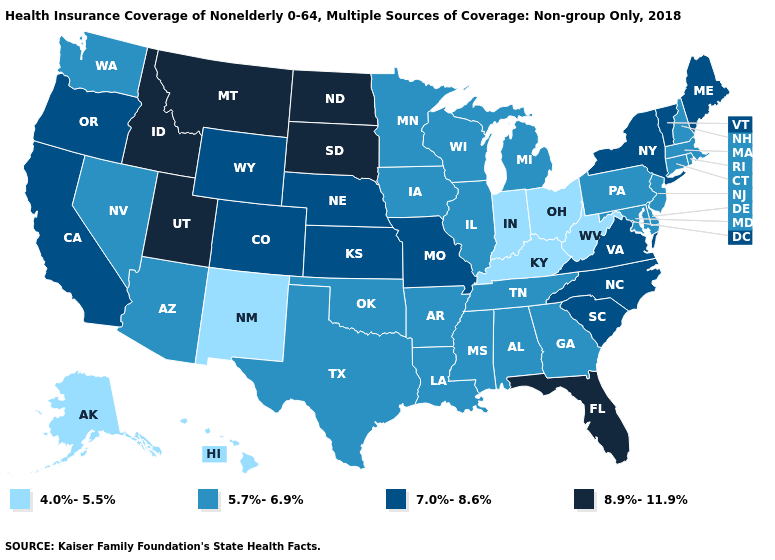What is the highest value in the USA?
Write a very short answer. 8.9%-11.9%. What is the value of South Carolina?
Concise answer only. 7.0%-8.6%. Among the states that border Vermont , which have the lowest value?
Concise answer only. Massachusetts, New Hampshire. Which states have the highest value in the USA?
Write a very short answer. Florida, Idaho, Montana, North Dakota, South Dakota, Utah. Among the states that border South Carolina , which have the highest value?
Write a very short answer. North Carolina. What is the value of Florida?
Answer briefly. 8.9%-11.9%. What is the value of Pennsylvania?
Write a very short answer. 5.7%-6.9%. What is the value of Washington?
Write a very short answer. 5.7%-6.9%. Does New Jersey have the lowest value in the Northeast?
Concise answer only. Yes. Does Montana have the highest value in the USA?
Write a very short answer. Yes. Does Connecticut have the lowest value in the Northeast?
Give a very brief answer. Yes. What is the value of Arizona?
Short answer required. 5.7%-6.9%. What is the highest value in the USA?
Give a very brief answer. 8.9%-11.9%. What is the lowest value in the Northeast?
Give a very brief answer. 5.7%-6.9%. What is the highest value in the USA?
Quick response, please. 8.9%-11.9%. 